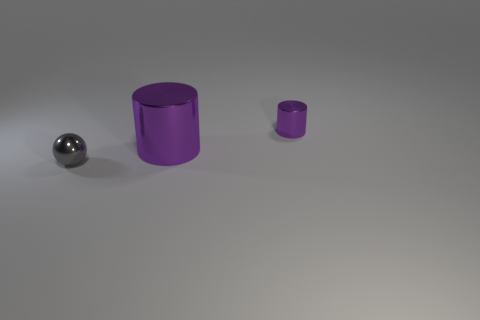Add 1 large gray cubes. How many objects exist? 4 Subtract all balls. How many objects are left? 2 Subtract all tiny gray metallic balls. Subtract all gray balls. How many objects are left? 1 Add 1 tiny purple metallic objects. How many tiny purple metallic objects are left? 2 Add 1 purple objects. How many purple objects exist? 3 Subtract 0 gray cylinders. How many objects are left? 3 